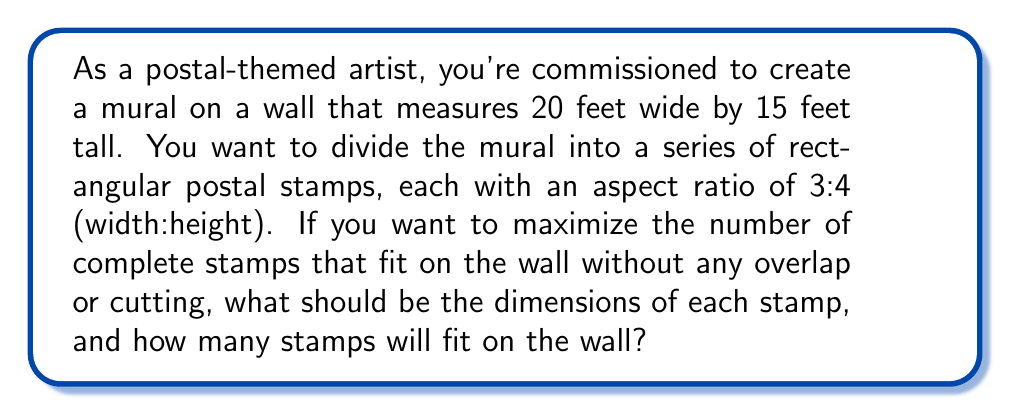Give your solution to this math problem. Let's approach this step-by-step:

1) First, let's define variables:
   Let $x$ be the width of each stamp in feet
   Let $y$ be the height of each stamp in feet

2) We know the aspect ratio is 3:4, so:
   $$\frac{x}{y} = \frac{3}{4}$$
   
3) This means $x = \frac{3}{4}y$

4) Now, we need to find how many stamps fit in each dimension:
   Width: $\frac{20}{x}$ stamps
   Height: $\frac{15}{y}$ stamps

5) The total number of stamps is the product of these:
   $$N = \frac{20}{x} \cdot \frac{15}{y} = \frac{300}{xy}$$

6) Substituting $x = \frac{3}{4}y$:
   $$N = \frac{300}{(\frac{3}{4}y)y} = \frac{400}{y^2}$$

7) We want to maximize N, which means we need to find the largest value of $\frac{400}{y^2}$ that results in a whole number of stamps in both dimensions.

8) Let's try some values:
   If $y = 1$, $x = 0.75$, we get $26 \times 15 = 390$ stamps (but $x$ isn't a whole number)
   If $y = 1.5$, $x = 1.125$, we get $17.\overline{7} \times 10 = 177.\overline{7}$ stamps (not whole numbers)
   If $y = 2$, $x = 1.5$, we get $13.\overline{3} \times 7.5 = 100$ stamps (not whole numbers)
   If $y = 3$, $x = 2.25$, we get $8.\overline{8} \times 5 = 44.\overline{4}$ stamps (not whole numbers)
   If $y = 5$, $x = 3.75$, we get $5.\overline{3} \times 3 = 16$ stamps (whole number, but not optimal)

9) The optimal solution is when $y = 3$ and $x = 2.25$, which gives us $8 \times 5 = 40$ stamps.

10) To verify:
    8 stamps of width 2.25 feet = 18 feet < 20 feet (fits width)
    5 stamps of height 3 feet = 15 feet (fits height perfectly)
Answer: The optimal dimensions for each stamp are 2.25 feet wide by 3 feet tall. This will allow for 40 stamps to fit on the wall (8 across and 5 down). 